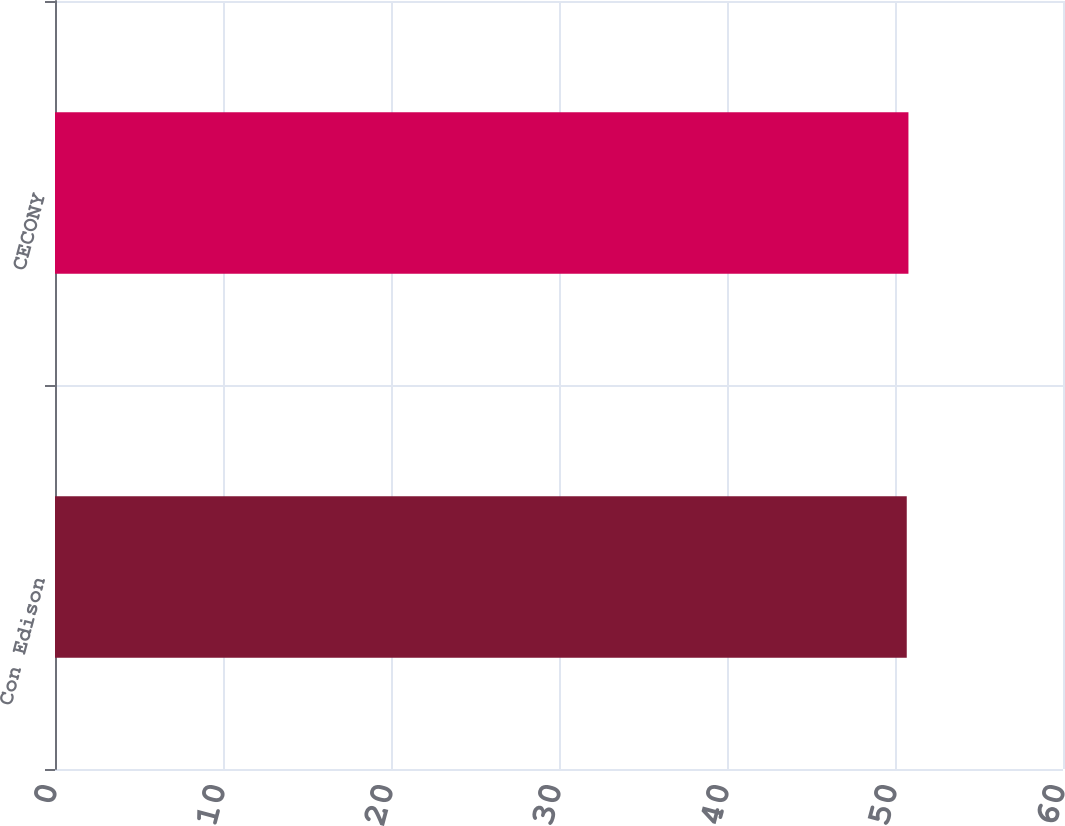Convert chart. <chart><loc_0><loc_0><loc_500><loc_500><bar_chart><fcel>Con Edison<fcel>CECONY<nl><fcel>50.7<fcel>50.8<nl></chart> 